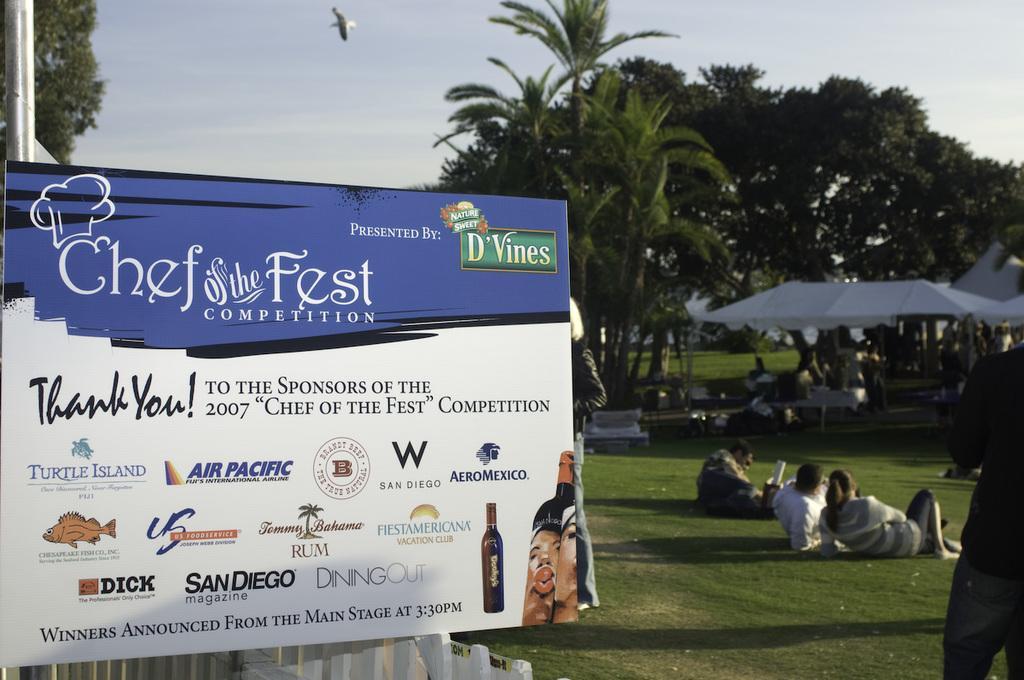How would you summarize this image in a sentence or two? Here in this picture, in the front we can see a board present over a place and on that we can see some pictures and text printed and beside that on the ground we can see some people sitting and we can also see tents present, under that we can see some people sitting on chairs and we can see the ground is fully covered with grass and we can see plants and trees present and we can see a bird flying in the air and we can see the sky is cloudy. 